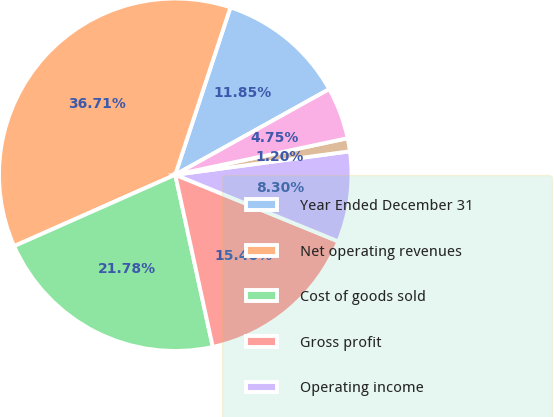Convert chart to OTSL. <chart><loc_0><loc_0><loc_500><loc_500><pie_chart><fcel>Year Ended December 31<fcel>Net operating revenues<fcel>Cost of goods sold<fcel>Gross profit<fcel>Operating income<fcel>Net income<fcel>Net income available to common<nl><fcel>11.85%<fcel>36.7%<fcel>21.77%<fcel>15.4%<fcel>8.3%<fcel>1.2%<fcel>4.75%<nl></chart> 